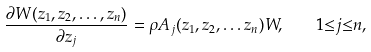<formula> <loc_0><loc_0><loc_500><loc_500>\frac { { \partial } W ( z _ { 1 } , z _ { 2 } , \dots , z _ { n } ) } { { \partial } z _ { j } } = { \rho } A _ { j } ( z _ { 1 } , z _ { 2 } , \dots z _ { n } ) W , \quad 1 { \leq } j { \leq } n ,</formula> 